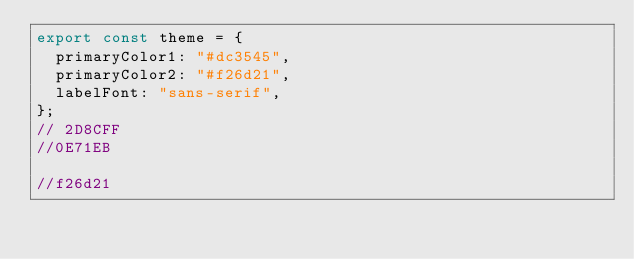Convert code to text. <code><loc_0><loc_0><loc_500><loc_500><_JavaScript_>export const theme = {
  primaryColor1: "#dc3545",
  primaryColor2: "#f26d21",
  labelFont: "sans-serif",
};
// 2D8CFF
//0E71EB

//f26d21
</code> 